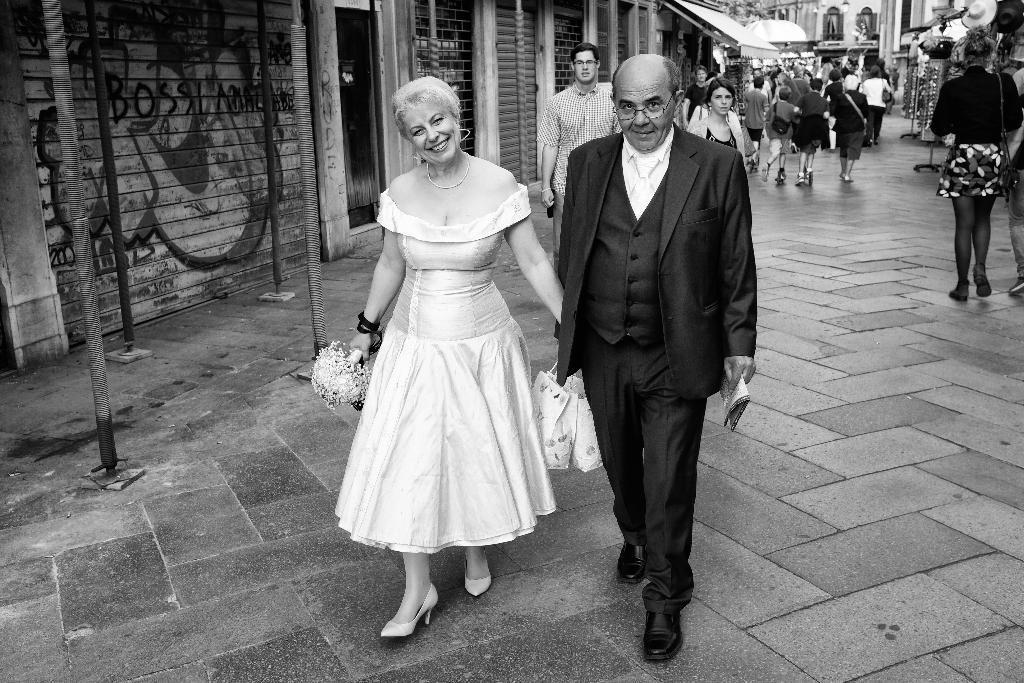Please provide a concise description of this image. This is a black and white image. I can see the man and woman walking. This woman is holding a flower bouquet and the man is holding two bags. I think these are the shops with doors. I can see the hats, which are hanging. I can see group of people walking. These are the poles. 